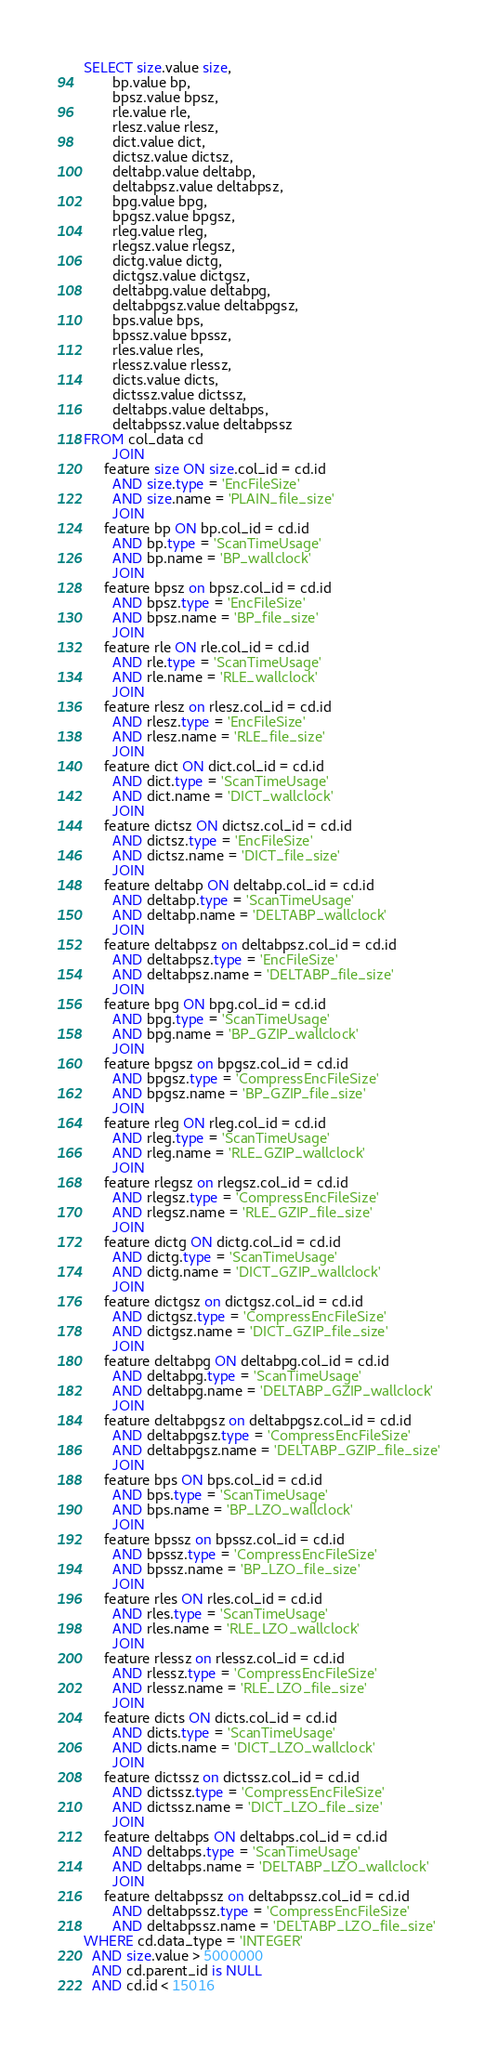<code> <loc_0><loc_0><loc_500><loc_500><_SQL_>SELECT size.value size,
       bp.value bp,
       bpsz.value bpsz,
       rle.value rle,
       rlesz.value rlesz,
       dict.value dict,
       dictsz.value dictsz,
       deltabp.value deltabp,
       deltabpsz.value deltabpsz,
       bpg.value bpg,
       bpgsz.value bpgsz,
       rleg.value rleg,
       rlegsz.value rlegsz,
       dictg.value dictg,
       dictgsz.value dictgsz,
       deltabpg.value deltabpg,
       deltabpgsz.value deltabpgsz,
       bps.value bps,
       bpssz.value bpssz,
       rles.value rles,
       rlessz.value rlessz,
       dicts.value dicts,
       dictssz.value dictssz,
       deltabps.value deltabps,
       deltabpssz.value deltabpssz
FROM col_data cd
       JOIN
     feature size ON size.col_id = cd.id
       AND size.type = 'EncFileSize'
       AND size.name = 'PLAIN_file_size'
       JOIN
     feature bp ON bp.col_id = cd.id
       AND bp.type = 'ScanTimeUsage'
       AND bp.name = 'BP_wallclock'
       JOIN
     feature bpsz on bpsz.col_id = cd.id
       AND bpsz.type = 'EncFileSize'
       AND bpsz.name = 'BP_file_size'
       JOIN
     feature rle ON rle.col_id = cd.id
       AND rle.type = 'ScanTimeUsage'
       AND rle.name = 'RLE_wallclock'
       JOIN
     feature rlesz on rlesz.col_id = cd.id
       AND rlesz.type = 'EncFileSize'
       AND rlesz.name = 'RLE_file_size'
       JOIN
     feature dict ON dict.col_id = cd.id
       AND dict.type = 'ScanTimeUsage'
       AND dict.name = 'DICT_wallclock'
       JOIN
     feature dictsz ON dictsz.col_id = cd.id
       AND dictsz.type = 'EncFileSize'
       AND dictsz.name = 'DICT_file_size'
       JOIN
     feature deltabp ON deltabp.col_id = cd.id
       AND deltabp.type = 'ScanTimeUsage'
       AND deltabp.name = 'DELTABP_wallclock'
       JOIN
     feature deltabpsz on deltabpsz.col_id = cd.id
       AND deltabpsz.type = 'EncFileSize'
       AND deltabpsz.name = 'DELTABP_file_size'
       JOIN
     feature bpg ON bpg.col_id = cd.id
       AND bpg.type = 'ScanTimeUsage'
       AND bpg.name = 'BP_GZIP_wallclock'
       JOIN
     feature bpgsz on bpgsz.col_id = cd.id
       AND bpgsz.type = 'CompressEncFileSize'
       AND bpgsz.name = 'BP_GZIP_file_size'
       JOIN
     feature rleg ON rleg.col_id = cd.id
       AND rleg.type = 'ScanTimeUsage'
       AND rleg.name = 'RLE_GZIP_wallclock'
       JOIN
     feature rlegsz on rlegsz.col_id = cd.id
       AND rlegsz.type = 'CompressEncFileSize'
       AND rlegsz.name = 'RLE_GZIP_file_size'
       JOIN
     feature dictg ON dictg.col_id = cd.id
       AND dictg.type = 'ScanTimeUsage'
       AND dictg.name = 'DICT_GZIP_wallclock'
       JOIN
     feature dictgsz on dictgsz.col_id = cd.id
       AND dictgsz.type = 'CompressEncFileSize'
       AND dictgsz.name = 'DICT_GZIP_file_size'
       JOIN
     feature deltabpg ON deltabpg.col_id = cd.id
       AND deltabpg.type = 'ScanTimeUsage'
       AND deltabpg.name = 'DELTABP_GZIP_wallclock'
       JOIN
     feature deltabpgsz on deltabpgsz.col_id = cd.id
       AND deltabpgsz.type = 'CompressEncFileSize'
       AND deltabpgsz.name = 'DELTABP_GZIP_file_size'
       JOIN
     feature bps ON bps.col_id = cd.id
       AND bps.type = 'ScanTimeUsage'
       AND bps.name = 'BP_LZO_wallclock'
       JOIN
     feature bpssz on bpssz.col_id = cd.id
       AND bpssz.type = 'CompressEncFileSize'
       AND bpssz.name = 'BP_LZO_file_size'
       JOIN
     feature rles ON rles.col_id = cd.id
       AND rles.type = 'ScanTimeUsage'
       AND rles.name = 'RLE_LZO_wallclock'
       JOIN
     feature rlessz on rlessz.col_id = cd.id
       AND rlessz.type = 'CompressEncFileSize'
       AND rlessz.name = 'RLE_LZO_file_size'
       JOIN
     feature dicts ON dicts.col_id = cd.id
       AND dicts.type = 'ScanTimeUsage'
       AND dicts.name = 'DICT_LZO_wallclock'
       JOIN
     feature dictssz on dictssz.col_id = cd.id
       AND dictssz.type = 'CompressEncFileSize'
       AND dictssz.name = 'DICT_LZO_file_size'
       JOIN
     feature deltabps ON deltabps.col_id = cd.id
       AND deltabps.type = 'ScanTimeUsage'
       AND deltabps.name = 'DELTABP_LZO_wallclock'
       JOIN
     feature deltabpssz on deltabpssz.col_id = cd.id
       AND deltabpssz.type = 'CompressEncFileSize'
       AND deltabpssz.name = 'DELTABP_LZO_file_size'
WHERE cd.data_type = 'INTEGER'
  AND size.value > 5000000
  AND cd.parent_id is NULL
  AND cd.id < 15016</code> 